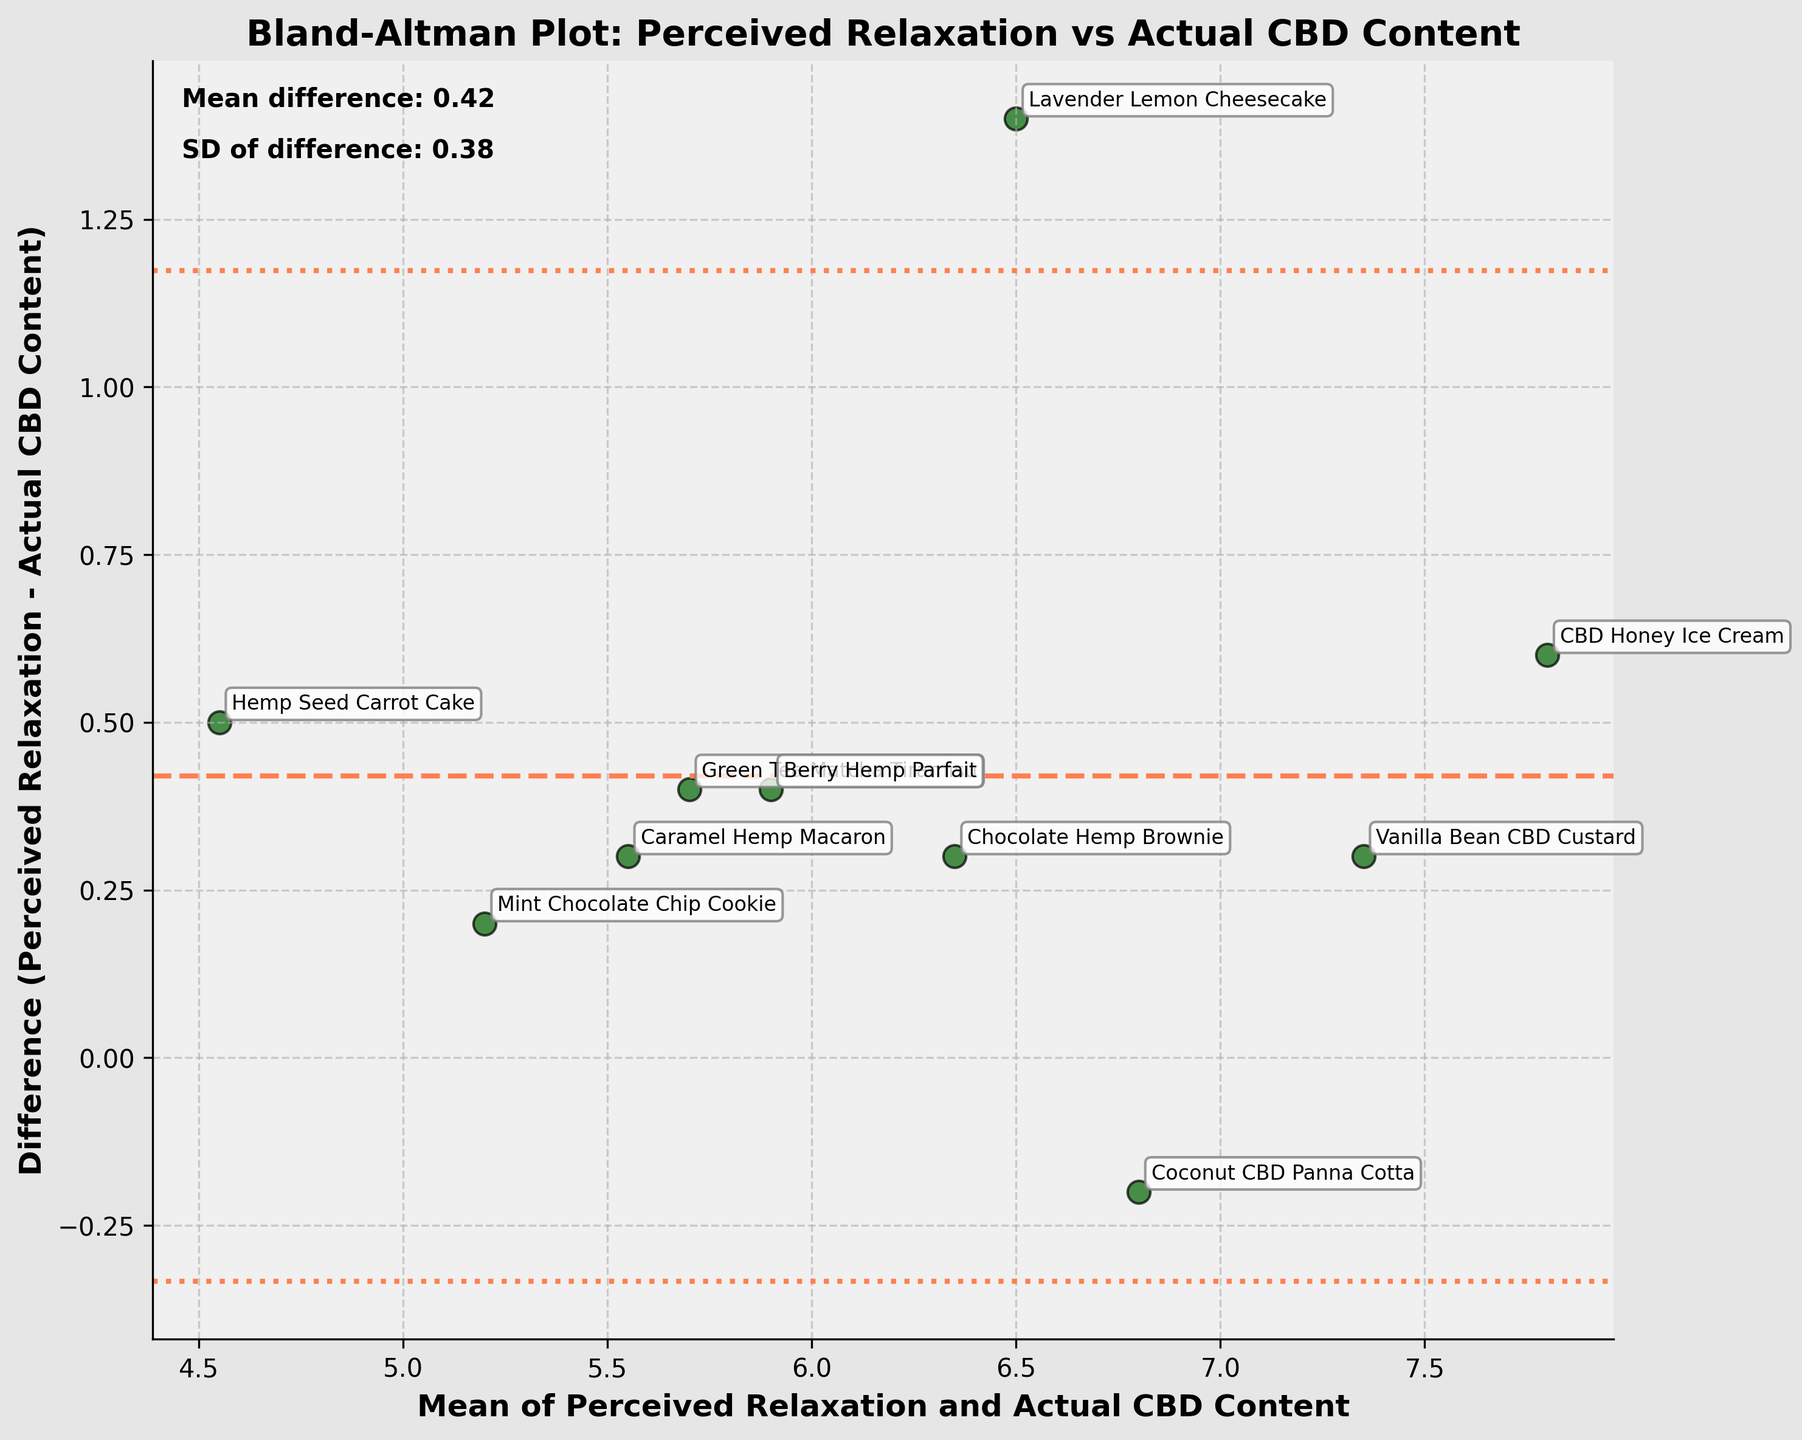What is the title of the plot? The title of the plot can be found at the top center of the figure. It is usually in a bold font for better visibility.
Answer: Bland-Altman Plot: Perceived Relaxation vs Actual CBD Content What are the axes labels? The axes labels are located along the horizontal and vertical axes of the plot. The horizontal axis label is at the bottom, and the vertical axis label is on the left side.
Answer: Horizontal: Mean of Perceived Relaxation and Actual CBD Content, Vertical: Difference (Perceived Relaxation - Actual CBD Content) How many data points are there in the plot? The number of data points corresponds to the number of dessert labels plotted as dots with annotations on the figure. Each label represents a distinct data point.
Answer: 10 What dessert has the largest positive difference between perceived relaxation and actual CBD content? To identify the dessert with the largest positive difference, find the data point that is farthest above the central mean difference line (coral dashed line). The corresponding dessert label will be the answer.
Answer: CBD Honey Ice Cream What is the mean difference shown by the horizontal coral dashed line? The mean difference is represented by the horizontal coral dashed line precisely crossing the vertical axis. This value is also annotated on the plot.
Answer: 0.42 Which dessert has a negative difference between perceived relaxation and actual CBD content? Negative differences are represented by data points below the central mean difference line. Identify the corresponding dessert labels for these data points.
Answer: Green Tea Matcha Tiramisu, Hemp Seed Carrot Cake, Caramel Hemp Macaron What are the upper and lower limits of agreement in the plot? The limits of agreement are indicated by the two coral dotted lines above and below the central mean difference line. The values are annotated around these lines.
Answer: Upper: 1.80, Lower: -0.96 Which dessert lies closest to the mean difference? Locate the data point that is closest to the central mean difference line. The corresponding dessert label adjacent to this data point indicates the answer.
Answer: Mint Chocolate Chip Cookie What is the standard deviation (SD) of the difference annotated on the plot? The standard deviation of the difference is annotated near the top left of the plot with the label "SD of difference." This value helps to understand the spread of the differences.
Answer: 0.70 How do the actual CBD content values compare to the perceived relaxation values? By observing the position of the data points relative to the central mean difference line, we can determine if perceived relaxation values are generally higher, lower, or similar to actual CBD content values. Note which side (above/below) the majority of the points lie.
Answer: Perceived relaxation values are slightly higher 